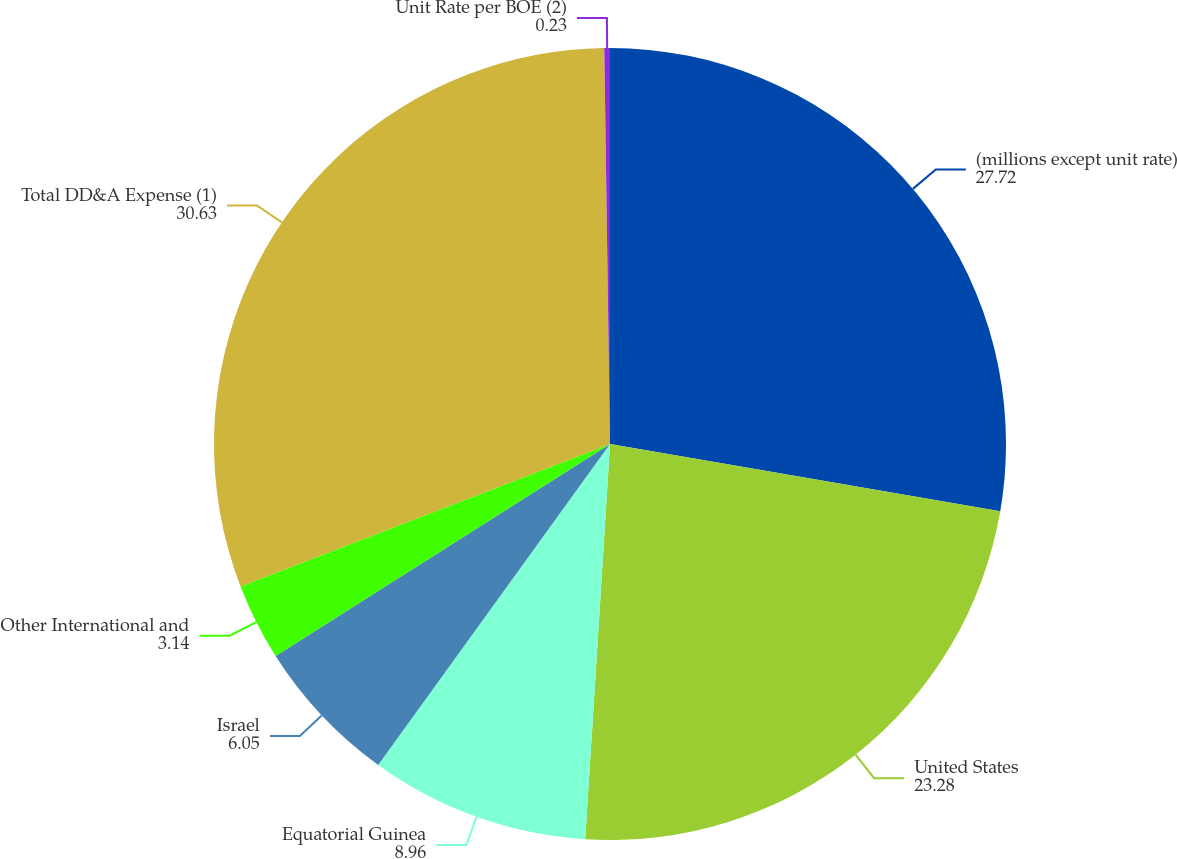<chart> <loc_0><loc_0><loc_500><loc_500><pie_chart><fcel>(millions except unit rate)<fcel>United States<fcel>Equatorial Guinea<fcel>Israel<fcel>Other International and<fcel>Total DD&A Expense (1)<fcel>Unit Rate per BOE (2)<nl><fcel>27.72%<fcel>23.28%<fcel>8.96%<fcel>6.05%<fcel>3.14%<fcel>30.63%<fcel>0.23%<nl></chart> 